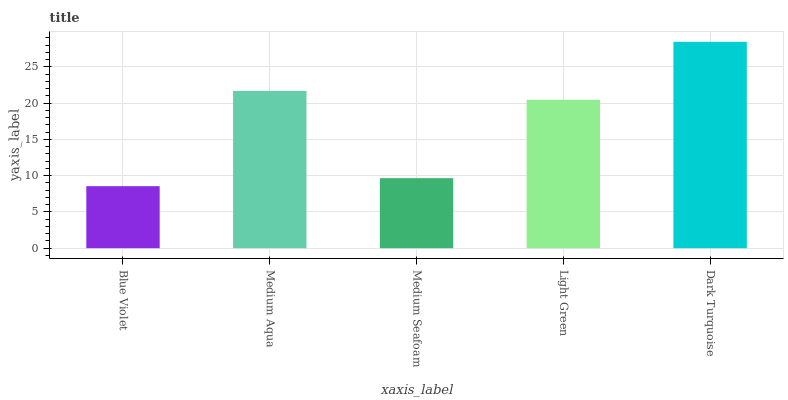Is Blue Violet the minimum?
Answer yes or no. Yes. Is Dark Turquoise the maximum?
Answer yes or no. Yes. Is Medium Aqua the minimum?
Answer yes or no. No. Is Medium Aqua the maximum?
Answer yes or no. No. Is Medium Aqua greater than Blue Violet?
Answer yes or no. Yes. Is Blue Violet less than Medium Aqua?
Answer yes or no. Yes. Is Blue Violet greater than Medium Aqua?
Answer yes or no. No. Is Medium Aqua less than Blue Violet?
Answer yes or no. No. Is Light Green the high median?
Answer yes or no. Yes. Is Light Green the low median?
Answer yes or no. Yes. Is Medium Aqua the high median?
Answer yes or no. No. Is Medium Seafoam the low median?
Answer yes or no. No. 